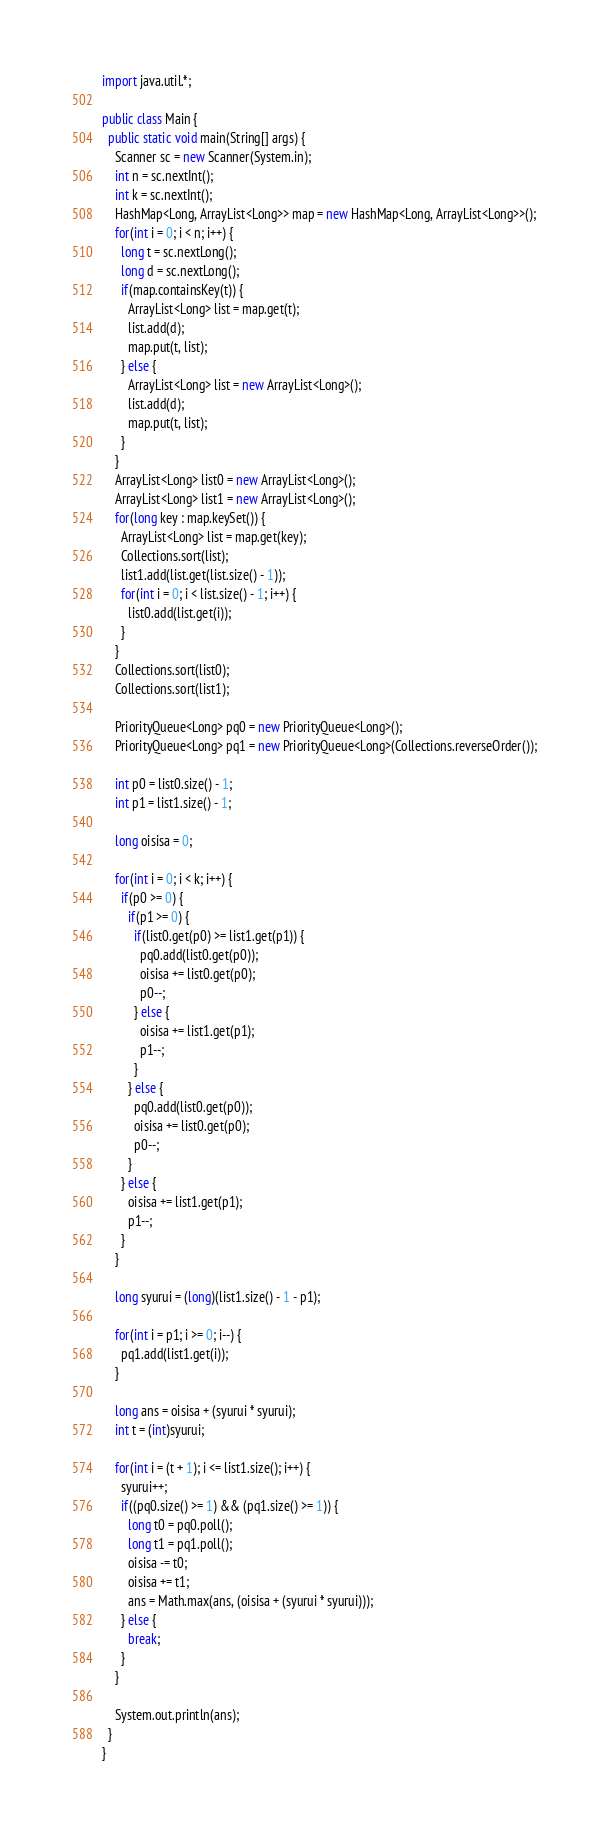<code> <loc_0><loc_0><loc_500><loc_500><_Java_>import java.util.*;

public class Main {
  public static void main(String[] args) {
    Scanner sc = new Scanner(System.in);
    int n = sc.nextInt();
    int k = sc.nextInt();
    HashMap<Long, ArrayList<Long>> map = new HashMap<Long, ArrayList<Long>>();
    for(int i = 0; i < n; i++) {
      long t = sc.nextLong();
      long d = sc.nextLong();
      if(map.containsKey(t)) {
        ArrayList<Long> list = map.get(t);
        list.add(d);
        map.put(t, list);
      } else {
        ArrayList<Long> list = new ArrayList<Long>();
        list.add(d);
        map.put(t, list);
      }
    }
    ArrayList<Long> list0 = new ArrayList<Long>();
    ArrayList<Long> list1 = new ArrayList<Long>();
    for(long key : map.keySet()) {
      ArrayList<Long> list = map.get(key);
      Collections.sort(list);
      list1.add(list.get(list.size() - 1));
      for(int i = 0; i < list.size() - 1; i++) {
        list0.add(list.get(i));
      }
    }
    Collections.sort(list0);
    Collections.sort(list1);

    PriorityQueue<Long> pq0 = new PriorityQueue<Long>();
    PriorityQueue<Long> pq1 = new PriorityQueue<Long>(Collections.reverseOrder());

    int p0 = list0.size() - 1;
    int p1 = list1.size() - 1;

    long oisisa = 0;

    for(int i = 0; i < k; i++) {
      if(p0 >= 0) {
        if(p1 >= 0) {
          if(list0.get(p0) >= list1.get(p1)) {
            pq0.add(list0.get(p0));
            oisisa += list0.get(p0);
            p0--;
          } else {
            oisisa += list1.get(p1);
            p1--;
          }
        } else {
          pq0.add(list0.get(p0));
          oisisa += list0.get(p0);
          p0--;
        }
      } else {
        oisisa += list1.get(p1);
        p1--;
      }
    }

    long syurui = (long)(list1.size() - 1 - p1);

    for(int i = p1; i >= 0; i--) {
      pq1.add(list1.get(i));
    }
    
    long ans = oisisa + (syurui * syurui);
    int t = (int)syurui;
    
    for(int i = (t + 1); i <= list1.size(); i++) {
      syurui++;
      if((pq0.size() >= 1) && (pq1.size() >= 1)) {
        long t0 = pq0.poll();
        long t1 = pq1.poll();
        oisisa -= t0;
        oisisa += t1;
        ans = Math.max(ans, (oisisa + (syurui * syurui)));
      } else {
        break;
      }
    }    

    System.out.println(ans);
  }
}</code> 